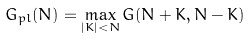<formula> <loc_0><loc_0><loc_500><loc_500>G _ { p l } ( N ) = \max _ { | K | < N } G ( N + K , N - K )</formula> 